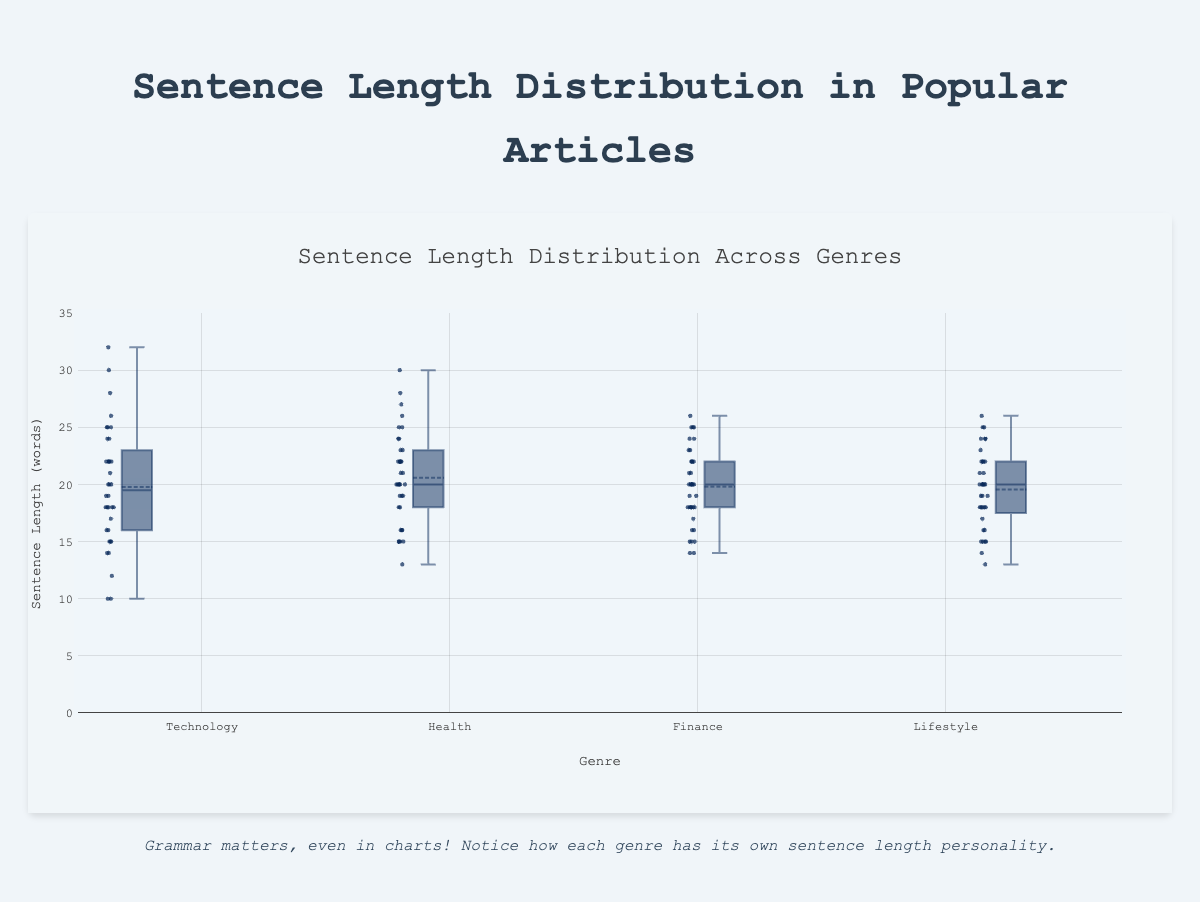What's the title of the figure? The title is displayed at the top of the figure in a larger font size and usually summarizes the content of the chart. In this case, it reads "Sentence Length Distribution Across Genres."
Answer: Sentence Length Distribution Across Genres What does the Y-axis represent? The label on the Y-axis indicates that it shows the "Sentence Length (words)," which means it measures the number of words in each sentence.
Answer: Sentence Length (words) Which genre has the highest median sentence length? The box plot's median is represented by the line inside the box. By comparing the median lines in each genre, it's clear that the "Lifestyle" genre has the highest median sentence length.
Answer: Lifestyle Compare the interquartile ranges of Technology and Health genres. Which is larger? The interquartile range (IQR) is represented by the height of the box, showing the range between the first and third quartiles. By visually comparing the heights of the boxes, the IQR for the Health genre is larger than that of the Technology genre.
Answer: Health What's the mean sentence length in the Finance genre according to the box plot? A dot or a line usually indicates the mean in a box plot. In this case, the mean sentence length for the Finance genre can be identified by looking for the marker that represents the mean.
Answer: Approximately 20 Which genre exhibits the greatest spread (range) in sentence lengths? The spread or range is indicated by the overall length of the whiskers (the lines that extend from the top and bottom of the box). By comparing these across genres, it's evident that the Technology genre has the greatest spread.
Answer: Technology Is the sentence length in the Lifestyle genre more consistent compared to the Finance genre? Consistency is indicated by a smaller spread (shorter whiskers) and a tighter interquartile range. By comparing the width of the boxes and the length of the whiskers, the Lifestyle genre appears to have more consistency than the Finance genre.
Answer: Yes Which genre has its first quartile closer to its median? The first quartile is where the lower edge of the box is, and the median is inside the box. By comparing the distance between these two points for each genre, the Health genre has its first quartile closer to its median than the others.
Answer: Health 